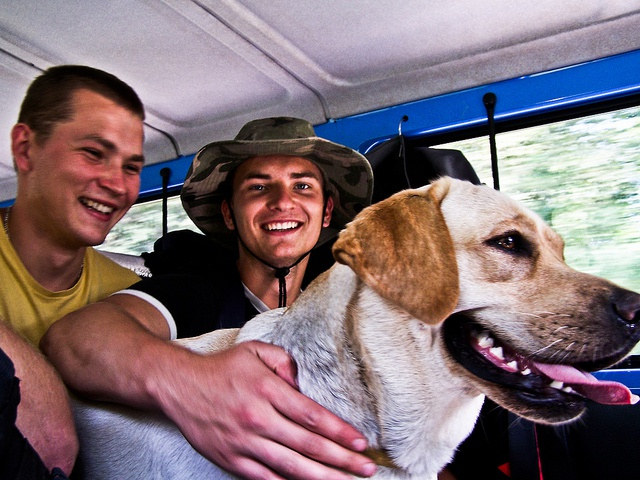Describe the objects in this image and their specific colors. I can see dog in gray, lightgray, black, and darkgray tones, people in gray, black, brown, maroon, and lightpink tones, and people in gray, maroon, black, brown, and olive tones in this image. 